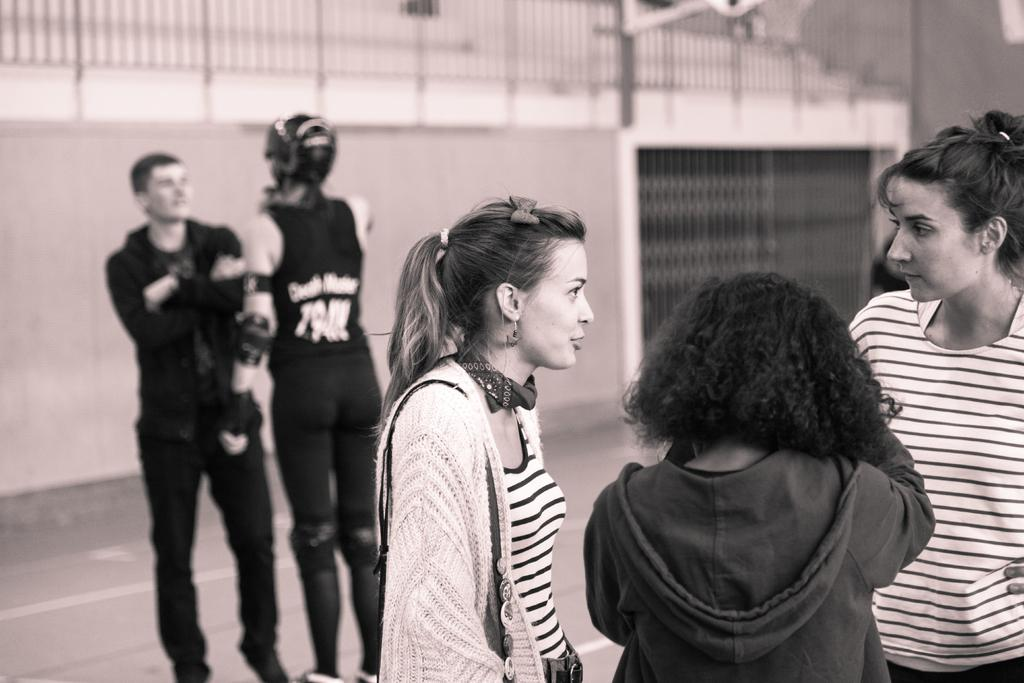Where are the people located in the image? There are people on both the right and left sides of the image. What can be seen in the background of the image? There is a net in the background of the image. What type of toys can be seen in the image? There are no toys present in the image. Is there a cactus visible in the image? There is no cactus present in the image. 